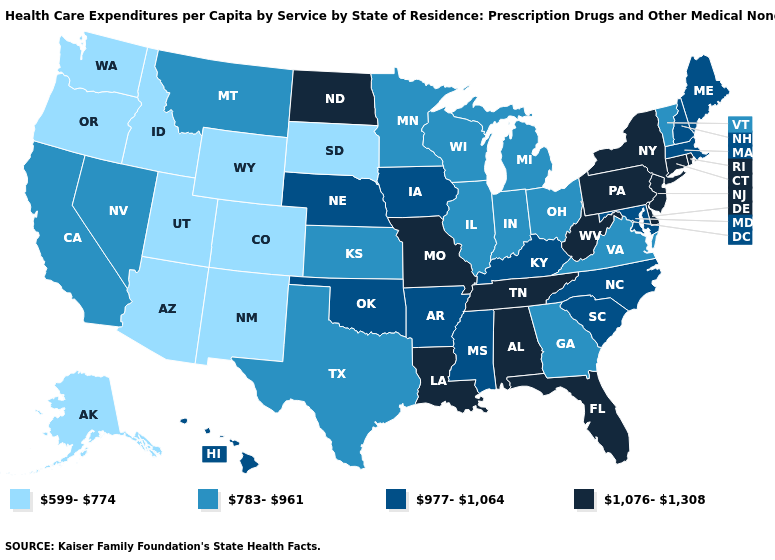Name the states that have a value in the range 977-1,064?
Concise answer only. Arkansas, Hawaii, Iowa, Kentucky, Maine, Maryland, Massachusetts, Mississippi, Nebraska, New Hampshire, North Carolina, Oklahoma, South Carolina. Name the states that have a value in the range 977-1,064?
Give a very brief answer. Arkansas, Hawaii, Iowa, Kentucky, Maine, Maryland, Massachusetts, Mississippi, Nebraska, New Hampshire, North Carolina, Oklahoma, South Carolina. Among the states that border New York , does Vermont have the lowest value?
Concise answer only. Yes. Name the states that have a value in the range 599-774?
Give a very brief answer. Alaska, Arizona, Colorado, Idaho, New Mexico, Oregon, South Dakota, Utah, Washington, Wyoming. What is the value of Wyoming?
Be succinct. 599-774. What is the value of Tennessee?
Quick response, please. 1,076-1,308. What is the highest value in the USA?
Write a very short answer. 1,076-1,308. Does Oregon have the highest value in the USA?
Concise answer only. No. What is the lowest value in the USA?
Short answer required. 599-774. Among the states that border Mississippi , does Tennessee have the highest value?
Concise answer only. Yes. Name the states that have a value in the range 977-1,064?
Quick response, please. Arkansas, Hawaii, Iowa, Kentucky, Maine, Maryland, Massachusetts, Mississippi, Nebraska, New Hampshire, North Carolina, Oklahoma, South Carolina. Name the states that have a value in the range 1,076-1,308?
Answer briefly. Alabama, Connecticut, Delaware, Florida, Louisiana, Missouri, New Jersey, New York, North Dakota, Pennsylvania, Rhode Island, Tennessee, West Virginia. Among the states that border Kentucky , does Ohio have the lowest value?
Concise answer only. Yes. What is the lowest value in the MidWest?
Quick response, please. 599-774. What is the value of Kentucky?
Short answer required. 977-1,064. 